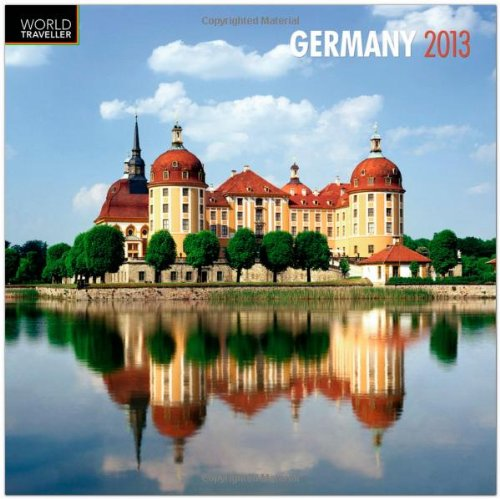Is this book related to Law? No, this calendar bears no relation to law or legal studies. It's solely a collection of images and dates focused on Germany for the year 2013. 